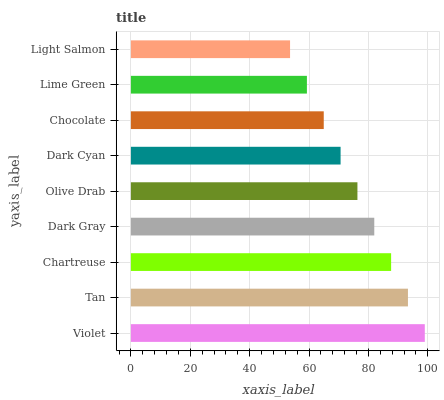Is Light Salmon the minimum?
Answer yes or no. Yes. Is Violet the maximum?
Answer yes or no. Yes. Is Tan the minimum?
Answer yes or no. No. Is Tan the maximum?
Answer yes or no. No. Is Violet greater than Tan?
Answer yes or no. Yes. Is Tan less than Violet?
Answer yes or no. Yes. Is Tan greater than Violet?
Answer yes or no. No. Is Violet less than Tan?
Answer yes or no. No. Is Olive Drab the high median?
Answer yes or no. Yes. Is Olive Drab the low median?
Answer yes or no. Yes. Is Tan the high median?
Answer yes or no. No. Is Lime Green the low median?
Answer yes or no. No. 